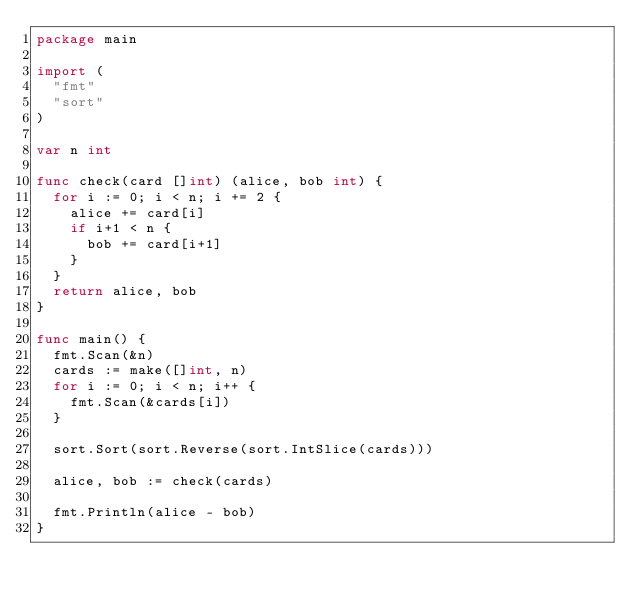Convert code to text. <code><loc_0><loc_0><loc_500><loc_500><_Go_>package main

import (
	"fmt"
	"sort"
)

var n int

func check(card []int) (alice, bob int) {
	for i := 0; i < n; i += 2 {
		alice += card[i]
		if i+1 < n {
			bob += card[i+1]
		}
	}
	return alice, bob
}

func main() {
	fmt.Scan(&n)
	cards := make([]int, n)
	for i := 0; i < n; i++ {
		fmt.Scan(&cards[i])
	}

	sort.Sort(sort.Reverse(sort.IntSlice(cards)))

	alice, bob := check(cards)

	fmt.Println(alice - bob)
}
</code> 